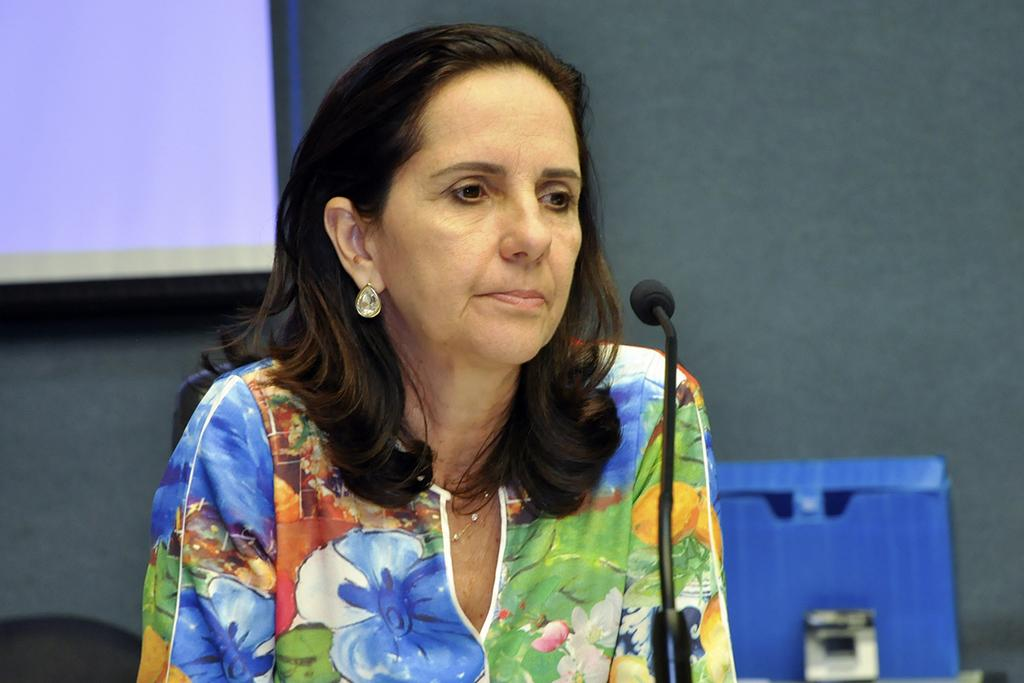Who is the main subject in the image? There is a woman in the image. What is the woman wearing? The woman is wearing a dress. What object is located in the foreground of the image? There is a microphone in the foreground of the image. What can be seen in the background of the image? There is a screen in the background of the image. What type of pipe can be seen in the woman's hand in the image? There is no pipe present in the woman's hand or anywhere else in the image. 